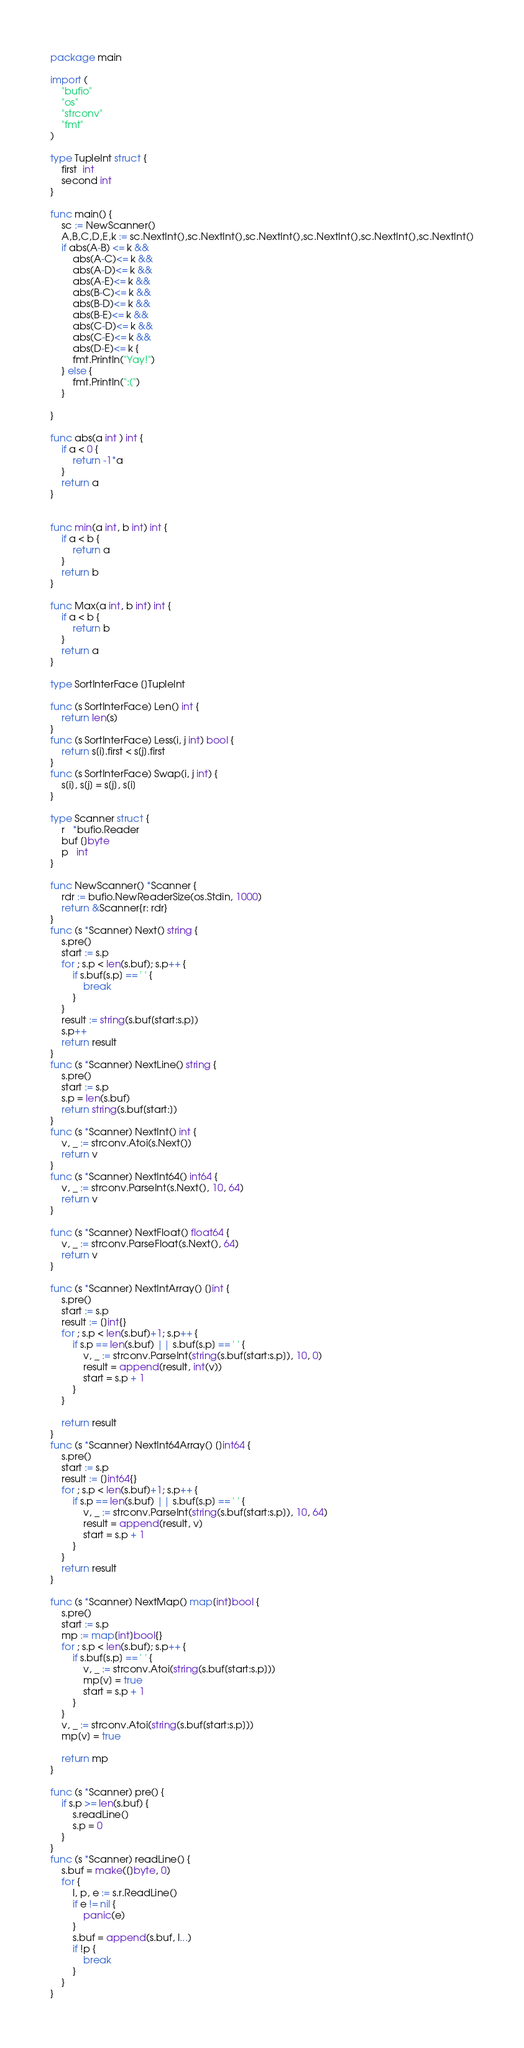Convert code to text. <code><loc_0><loc_0><loc_500><loc_500><_Go_>package main

import (
	"bufio"
	"os"
	"strconv"
	"fmt"
)

type TupleInt struct {
	first  int
	second int
}

func main() {
	sc := NewScanner()
	A,B,C,D,E,k := sc.NextInt(),sc.NextInt(),sc.NextInt(),sc.NextInt(),sc.NextInt(),sc.NextInt()
	if abs(A-B) <= k &&
		abs(A-C)<= k &&
		abs(A-D)<= k &&
		abs(A-E)<= k &&
		abs(B-C)<= k &&
		abs(B-D)<= k &&
		abs(B-E)<= k &&
		abs(C-D)<= k &&
		abs(C-E)<= k &&
		abs(D-E)<= k {
		fmt.Println("Yay!")
	} else {
		fmt.Println(":(")
	}

}

func abs(a int ) int {
	if a < 0 {
		return -1*a
	}
	return a
}


func min(a int, b int) int {
	if a < b {
		return a
	}
	return b
}

func Max(a int, b int) int {
	if a < b {
		return b
	}
	return a
}

type SortInterFace []TupleInt

func (s SortInterFace) Len() int {
	return len(s)
}
func (s SortInterFace) Less(i, j int) bool {
	return s[i].first < s[j].first
}
func (s SortInterFace) Swap(i, j int) {
	s[i], s[j] = s[j], s[i]
}

type Scanner struct {
	r   *bufio.Reader
	buf []byte
	p   int
}

func NewScanner() *Scanner {
	rdr := bufio.NewReaderSize(os.Stdin, 1000)
	return &Scanner{r: rdr}
}
func (s *Scanner) Next() string {
	s.pre()
	start := s.p
	for ; s.p < len(s.buf); s.p++ {
		if s.buf[s.p] == ' ' {
			break
		}
	}
	result := string(s.buf[start:s.p])
	s.p++
	return result
}
func (s *Scanner) NextLine() string {
	s.pre()
	start := s.p
	s.p = len(s.buf)
	return string(s.buf[start:])
}
func (s *Scanner) NextInt() int {
	v, _ := strconv.Atoi(s.Next())
	return v
}
func (s *Scanner) NextInt64() int64 {
	v, _ := strconv.ParseInt(s.Next(), 10, 64)
	return v
}

func (s *Scanner) NextFloat() float64 {
	v, _ := strconv.ParseFloat(s.Next(), 64)
	return v
}

func (s *Scanner) NextIntArray() []int {
	s.pre()
	start := s.p
	result := []int{}
	for ; s.p < len(s.buf)+1; s.p++ {
		if s.p == len(s.buf) || s.buf[s.p] == ' ' {
			v, _ := strconv.ParseInt(string(s.buf[start:s.p]), 10, 0)
			result = append(result, int(v))
			start = s.p + 1
		}
	}

	return result
}
func (s *Scanner) NextInt64Array() []int64 {
	s.pre()
	start := s.p
	result := []int64{}
	for ; s.p < len(s.buf)+1; s.p++ {
		if s.p == len(s.buf) || s.buf[s.p] == ' ' {
			v, _ := strconv.ParseInt(string(s.buf[start:s.p]), 10, 64)
			result = append(result, v)
			start = s.p + 1
		}
	}
	return result
}

func (s *Scanner) NextMap() map[int]bool {
	s.pre()
	start := s.p
	mp := map[int]bool{}
	for ; s.p < len(s.buf); s.p++ {
		if s.buf[s.p] == ' ' {
			v, _ := strconv.Atoi(string(s.buf[start:s.p]))
			mp[v] = true
			start = s.p + 1
		}
	}
	v, _ := strconv.Atoi(string(s.buf[start:s.p]))
	mp[v] = true

	return mp
}

func (s *Scanner) pre() {
	if s.p >= len(s.buf) {
		s.readLine()
		s.p = 0
	}
}
func (s *Scanner) readLine() {
	s.buf = make([]byte, 0)
	for {
		l, p, e := s.r.ReadLine()
		if e != nil {
			panic(e)
		}
		s.buf = append(s.buf, l...)
		if !p {
			break
		}
	}
}
</code> 